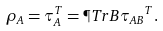<formula> <loc_0><loc_0><loc_500><loc_500>\rho _ { A } = \tau _ { A } ^ { T } = \P T r { B } { \tau _ { A B } } ^ { T } .</formula> 